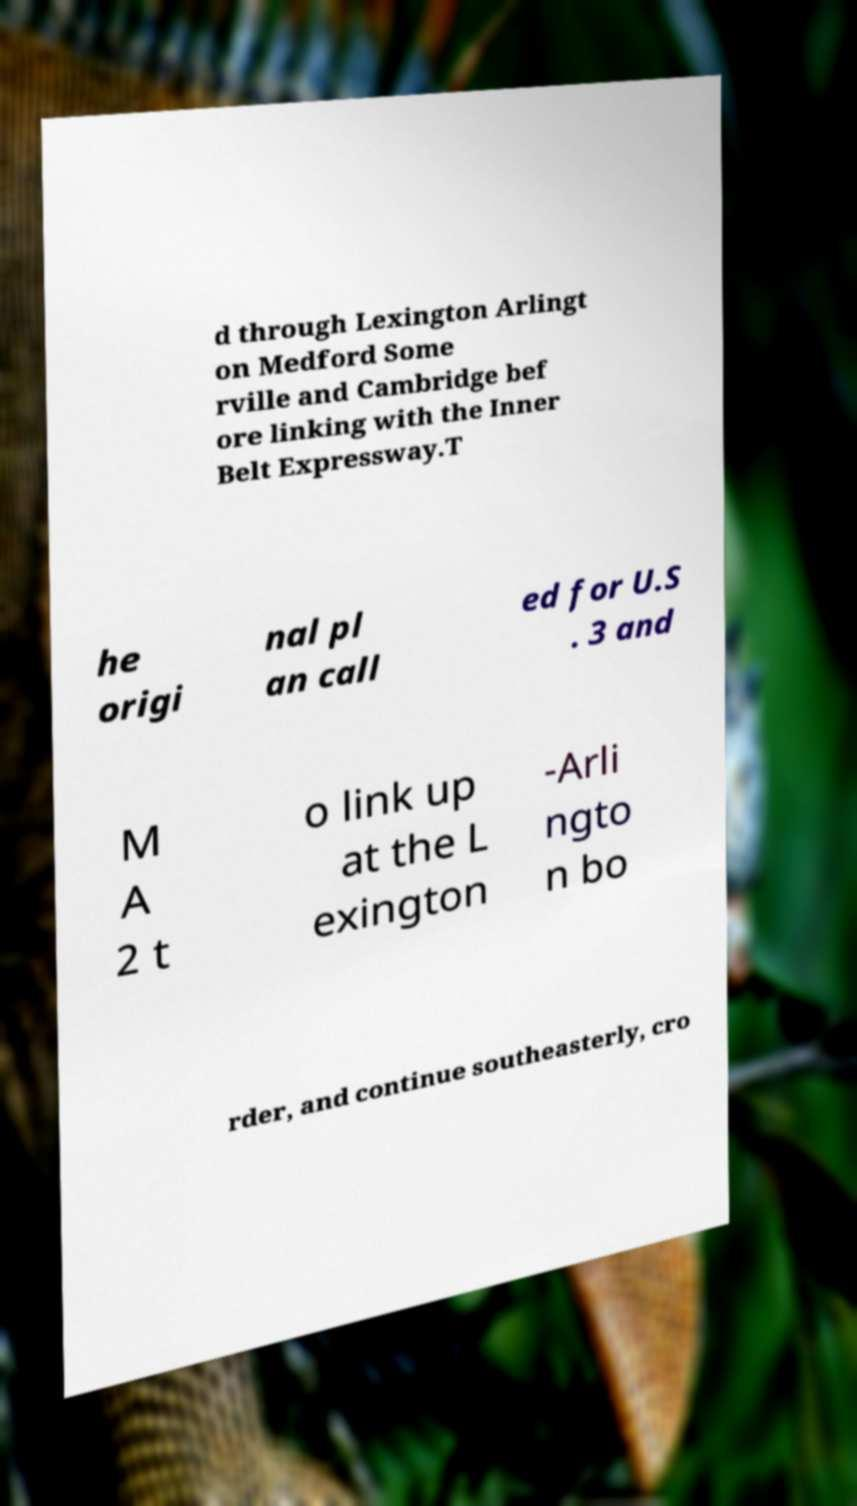Please read and relay the text visible in this image. What does it say? d through Lexington Arlingt on Medford Some rville and Cambridge bef ore linking with the Inner Belt Expressway.T he origi nal pl an call ed for U.S . 3 and M A 2 t o link up at the L exington -Arli ngto n bo rder, and continue southeasterly, cro 